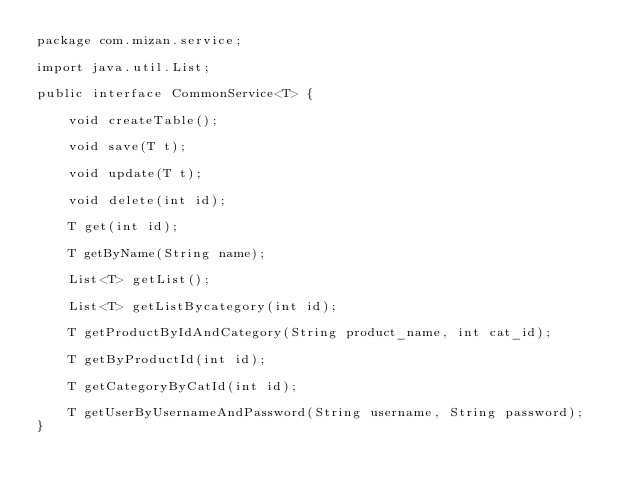Convert code to text. <code><loc_0><loc_0><loc_500><loc_500><_Java_>package com.mizan.service;

import java.util.List;

public interface CommonService<T> {

    void createTable();

    void save(T t);

    void update(T t);

    void delete(int id);

    T get(int id);

    T getByName(String name);

    List<T> getList();

    List<T> getListBycategory(int id);

    T getProductByIdAndCategory(String product_name, int cat_id);

    T getByProductId(int id);

    T getCategoryByCatId(int id);

    T getUserByUsernameAndPassword(String username, String password);
}
</code> 